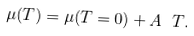<formula> <loc_0><loc_0><loc_500><loc_500>\mu ( T ) = \mu ( T = 0 ) + A \ T .</formula> 